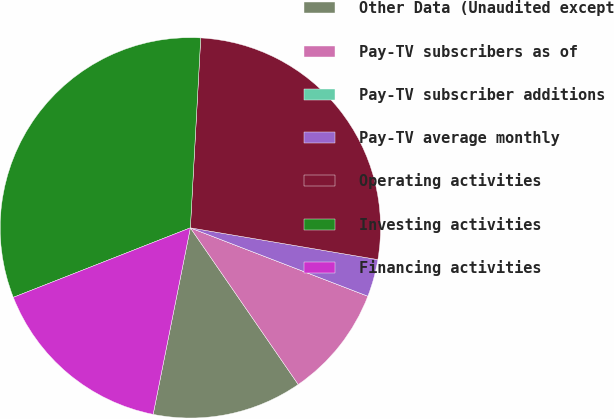<chart> <loc_0><loc_0><loc_500><loc_500><pie_chart><fcel>Other Data (Unaudited except<fcel>Pay-TV subscribers as of<fcel>Pay-TV subscriber additions<fcel>Pay-TV average monthly<fcel>Operating activities<fcel>Investing activities<fcel>Financing activities<nl><fcel>12.73%<fcel>9.55%<fcel>0.0%<fcel>3.18%<fcel>26.8%<fcel>31.82%<fcel>15.91%<nl></chart> 